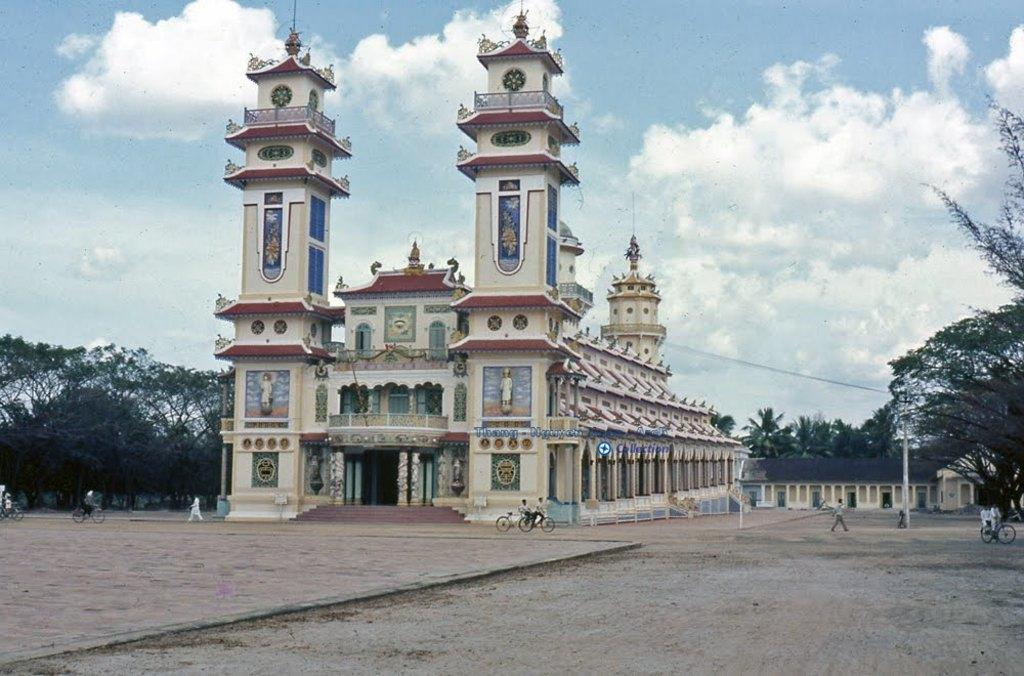What type of structure is visible in the image? There is a tall building in the image. What else can be seen in the image besides the tall building? Trees are present in the image. What are the people in the image doing? People are walking on the ground in the image. What color is the sky in the image? The sky is blue in the image. How many shoes can be seen on the tall building in the image? There are no shoes visible on the tall building in the image. What type of spoon is being used by the trees in the image? There are no spoons present in the image, and trees do not use spoons. 